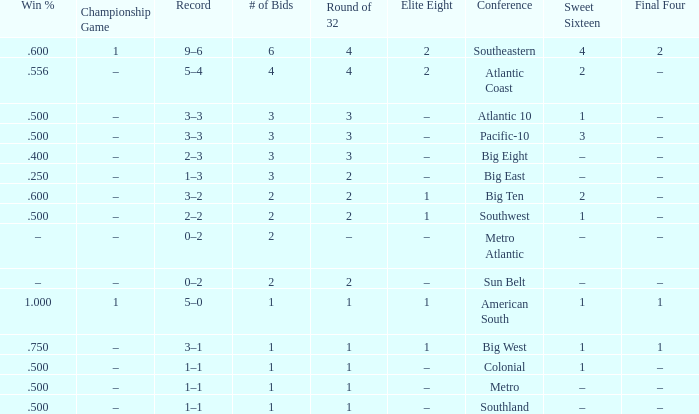What Sweet Sixteen team is in the Colonial conference? 1.0. 